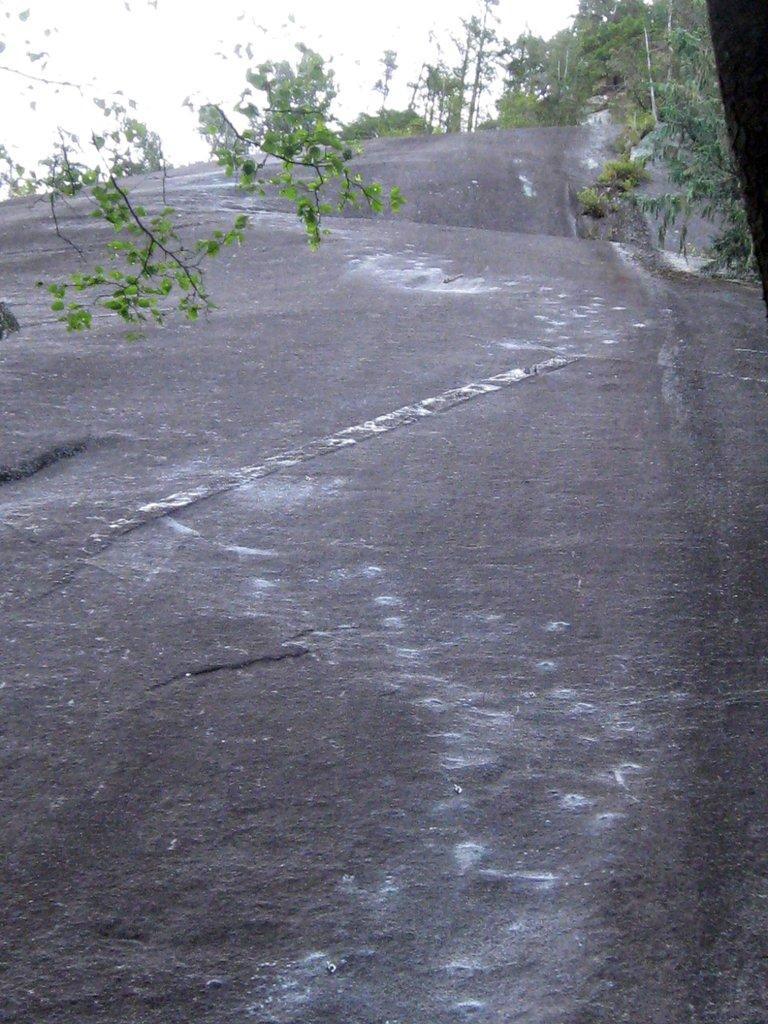Describe this image in one or two sentences. In this image I can see the sky and trees at the top this is picture is taken during the day. 